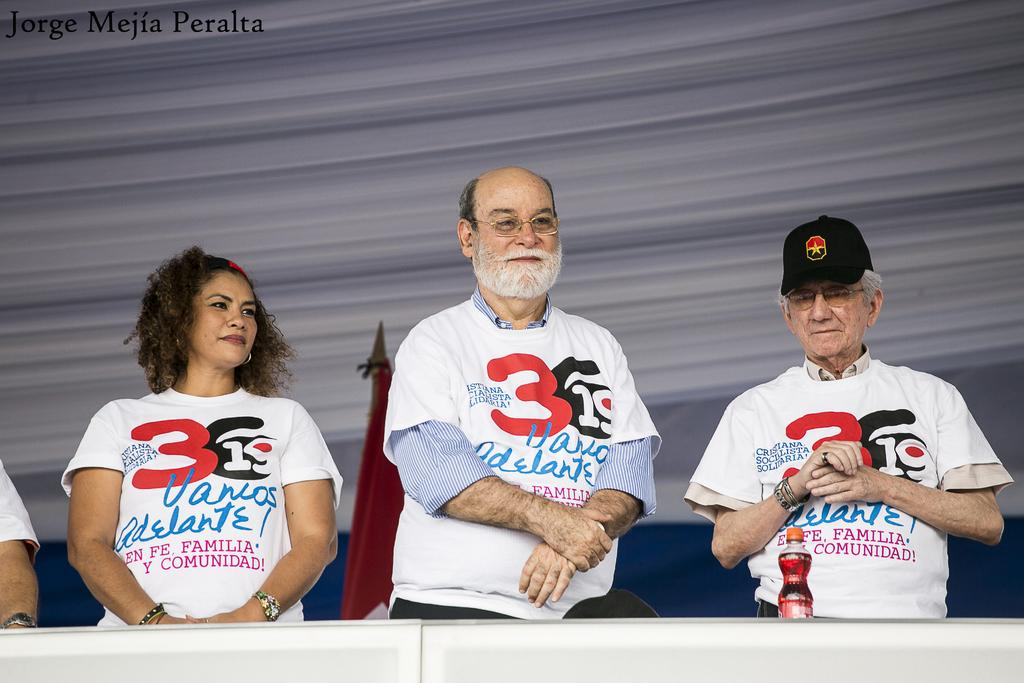<image>
Give a short and clear explanation of the subsequent image. 3 people standing in a row, all wearing shirts that read 3619 Vamos Adelante, the photo taken by Jorge Mejia Peralta 